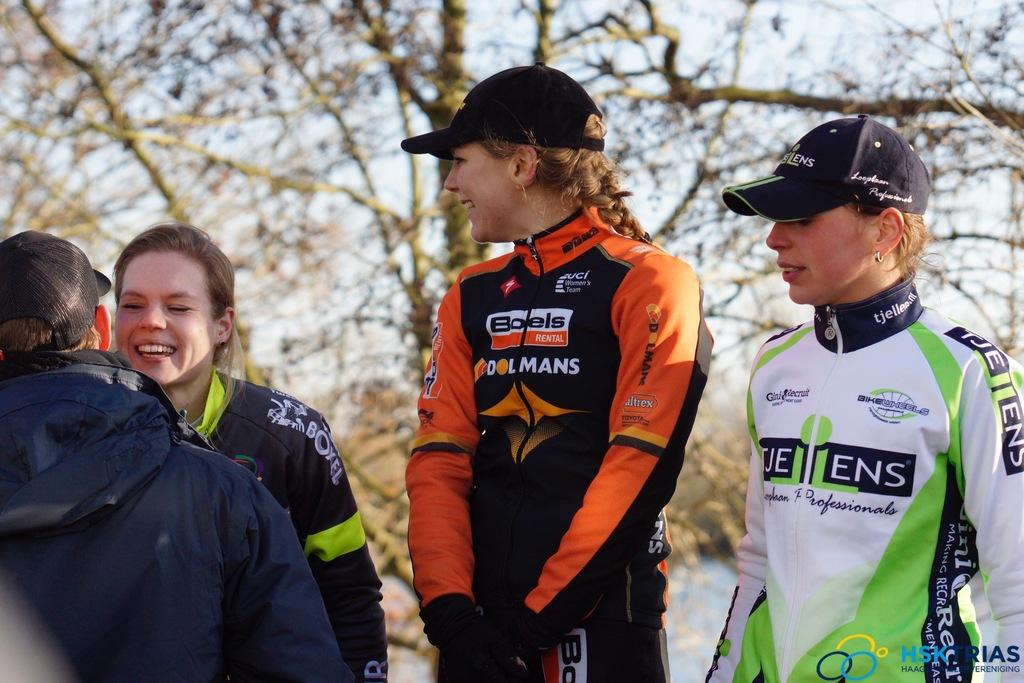<image>
Create a compact narrative representing the image presented. A kid has a jacket on with a Boels logo. 